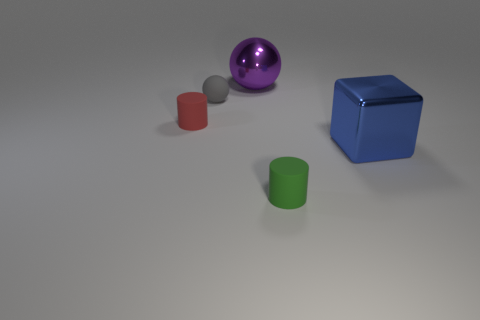Can you describe the positioning of the objects in relation to each other? Certainly! In the image, we see a collection of geometric objects on a flat surface. A purple shiny ball is positioned to the upper left, a red cylinder is on the middle left with a silver spherical object in front of it, a blue cube is to the right, and a green cylinder is in the foreground, slightly to the left. 